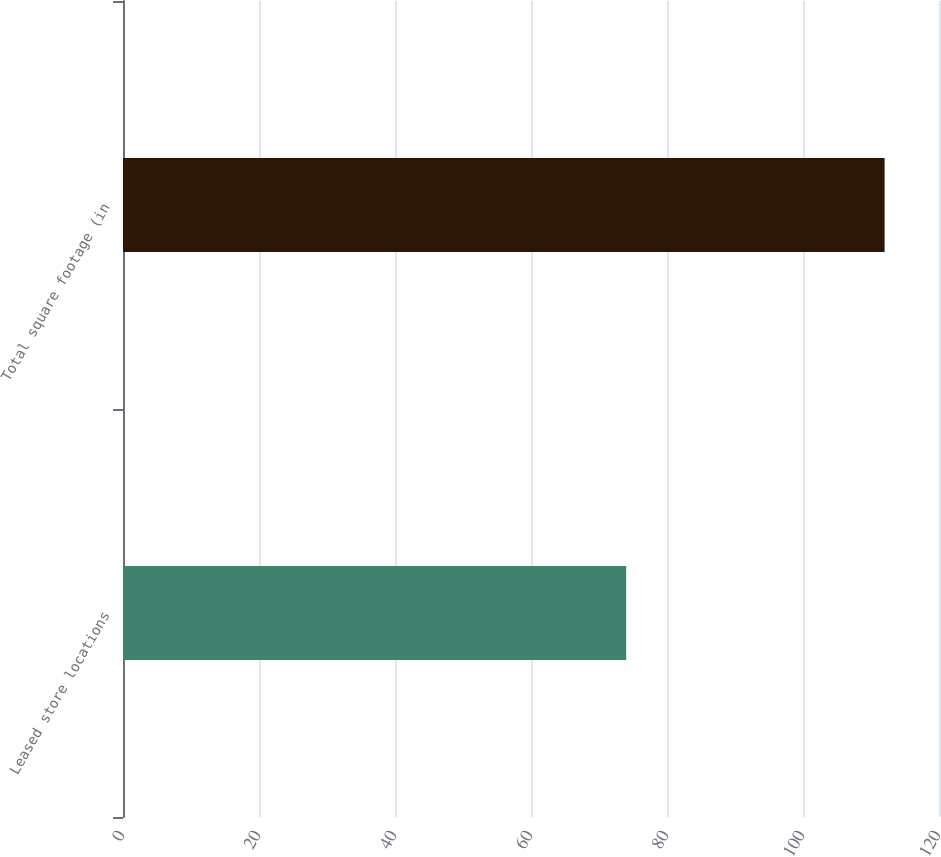Convert chart. <chart><loc_0><loc_0><loc_500><loc_500><bar_chart><fcel>Leased store locations<fcel>Total square footage (in<nl><fcel>74<fcel>112<nl></chart> 